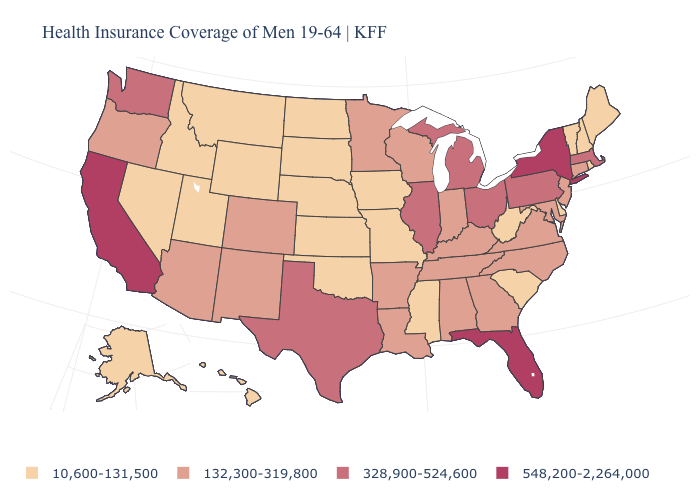Does the first symbol in the legend represent the smallest category?
Give a very brief answer. Yes. What is the value of Michigan?
Be succinct. 328,900-524,600. Name the states that have a value in the range 328,900-524,600?
Write a very short answer. Illinois, Massachusetts, Michigan, Ohio, Pennsylvania, Texas, Washington. Is the legend a continuous bar?
Concise answer only. No. Which states hav the highest value in the West?
Be succinct. California. Name the states that have a value in the range 132,300-319,800?
Write a very short answer. Alabama, Arizona, Arkansas, Colorado, Connecticut, Georgia, Indiana, Kentucky, Louisiana, Maryland, Minnesota, New Jersey, New Mexico, North Carolina, Oregon, Tennessee, Virginia, Wisconsin. What is the value of North Dakota?
Concise answer only. 10,600-131,500. What is the lowest value in the USA?
Short answer required. 10,600-131,500. How many symbols are there in the legend?
Keep it brief. 4. Among the states that border South Carolina , which have the lowest value?
Give a very brief answer. Georgia, North Carolina. What is the lowest value in states that border Massachusetts?
Quick response, please. 10,600-131,500. Does South Dakota have the lowest value in the USA?
Short answer required. Yes. Does New Jersey have a lower value than New Mexico?
Be succinct. No. Name the states that have a value in the range 10,600-131,500?
Short answer required. Alaska, Delaware, Hawaii, Idaho, Iowa, Kansas, Maine, Mississippi, Missouri, Montana, Nebraska, Nevada, New Hampshire, North Dakota, Oklahoma, Rhode Island, South Carolina, South Dakota, Utah, Vermont, West Virginia, Wyoming. 